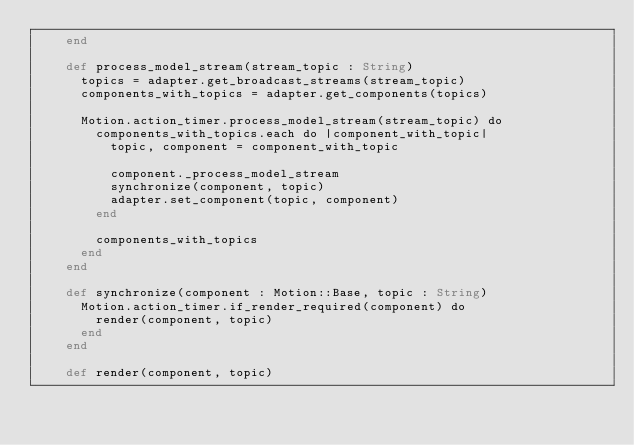Convert code to text. <code><loc_0><loc_0><loc_500><loc_500><_Crystal_>    end

    def process_model_stream(stream_topic : String)
      topics = adapter.get_broadcast_streams(stream_topic)
      components_with_topics = adapter.get_components(topics)

      Motion.action_timer.process_model_stream(stream_topic) do
        components_with_topics.each do |component_with_topic|
          topic, component = component_with_topic

          component._process_model_stream
          synchronize(component, topic)
          adapter.set_component(topic, component)
        end

        components_with_topics
      end
    end

    def synchronize(component : Motion::Base, topic : String)
      Motion.action_timer.if_render_required(component) do
        render(component, topic)
      end
    end

    def render(component, topic)</code> 